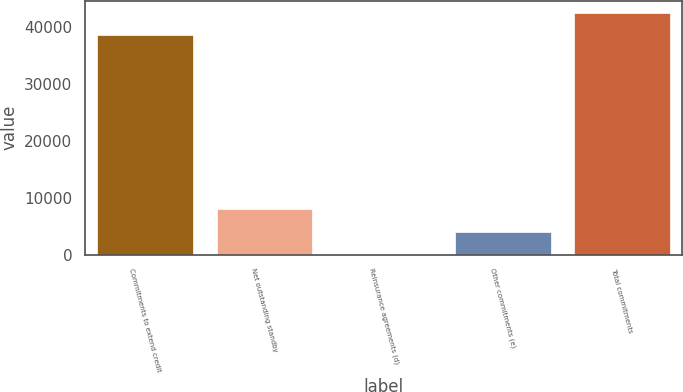Convert chart to OTSL. <chart><loc_0><loc_0><loc_500><loc_500><bar_chart><fcel>Commitments to extend credit<fcel>Net outstanding standby<fcel>Reinsurance agreements (d)<fcel>Other commitments (e)<fcel>Total commitments<nl><fcel>38617<fcel>7958.2<fcel>17<fcel>3987.6<fcel>42587.6<nl></chart> 